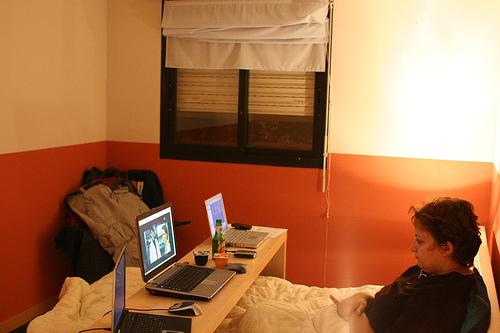What is the number of laptops sat on the bar held over this bed? three 